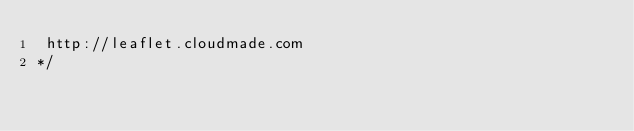<code> <loc_0><loc_0><loc_500><loc_500><_JavaScript_> http://leaflet.cloudmade.com
*/</code> 